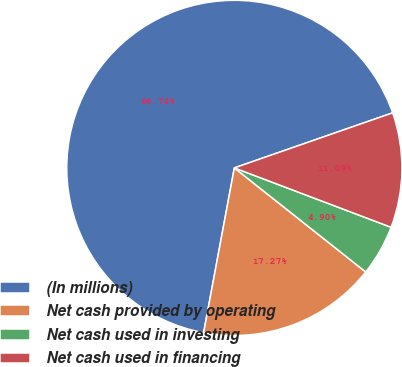Convert chart. <chart><loc_0><loc_0><loc_500><loc_500><pie_chart><fcel>(In millions)<fcel>Net cash provided by operating<fcel>Net cash used in investing<fcel>Net cash used in financing<nl><fcel>66.74%<fcel>17.27%<fcel>4.9%<fcel>11.09%<nl></chart> 